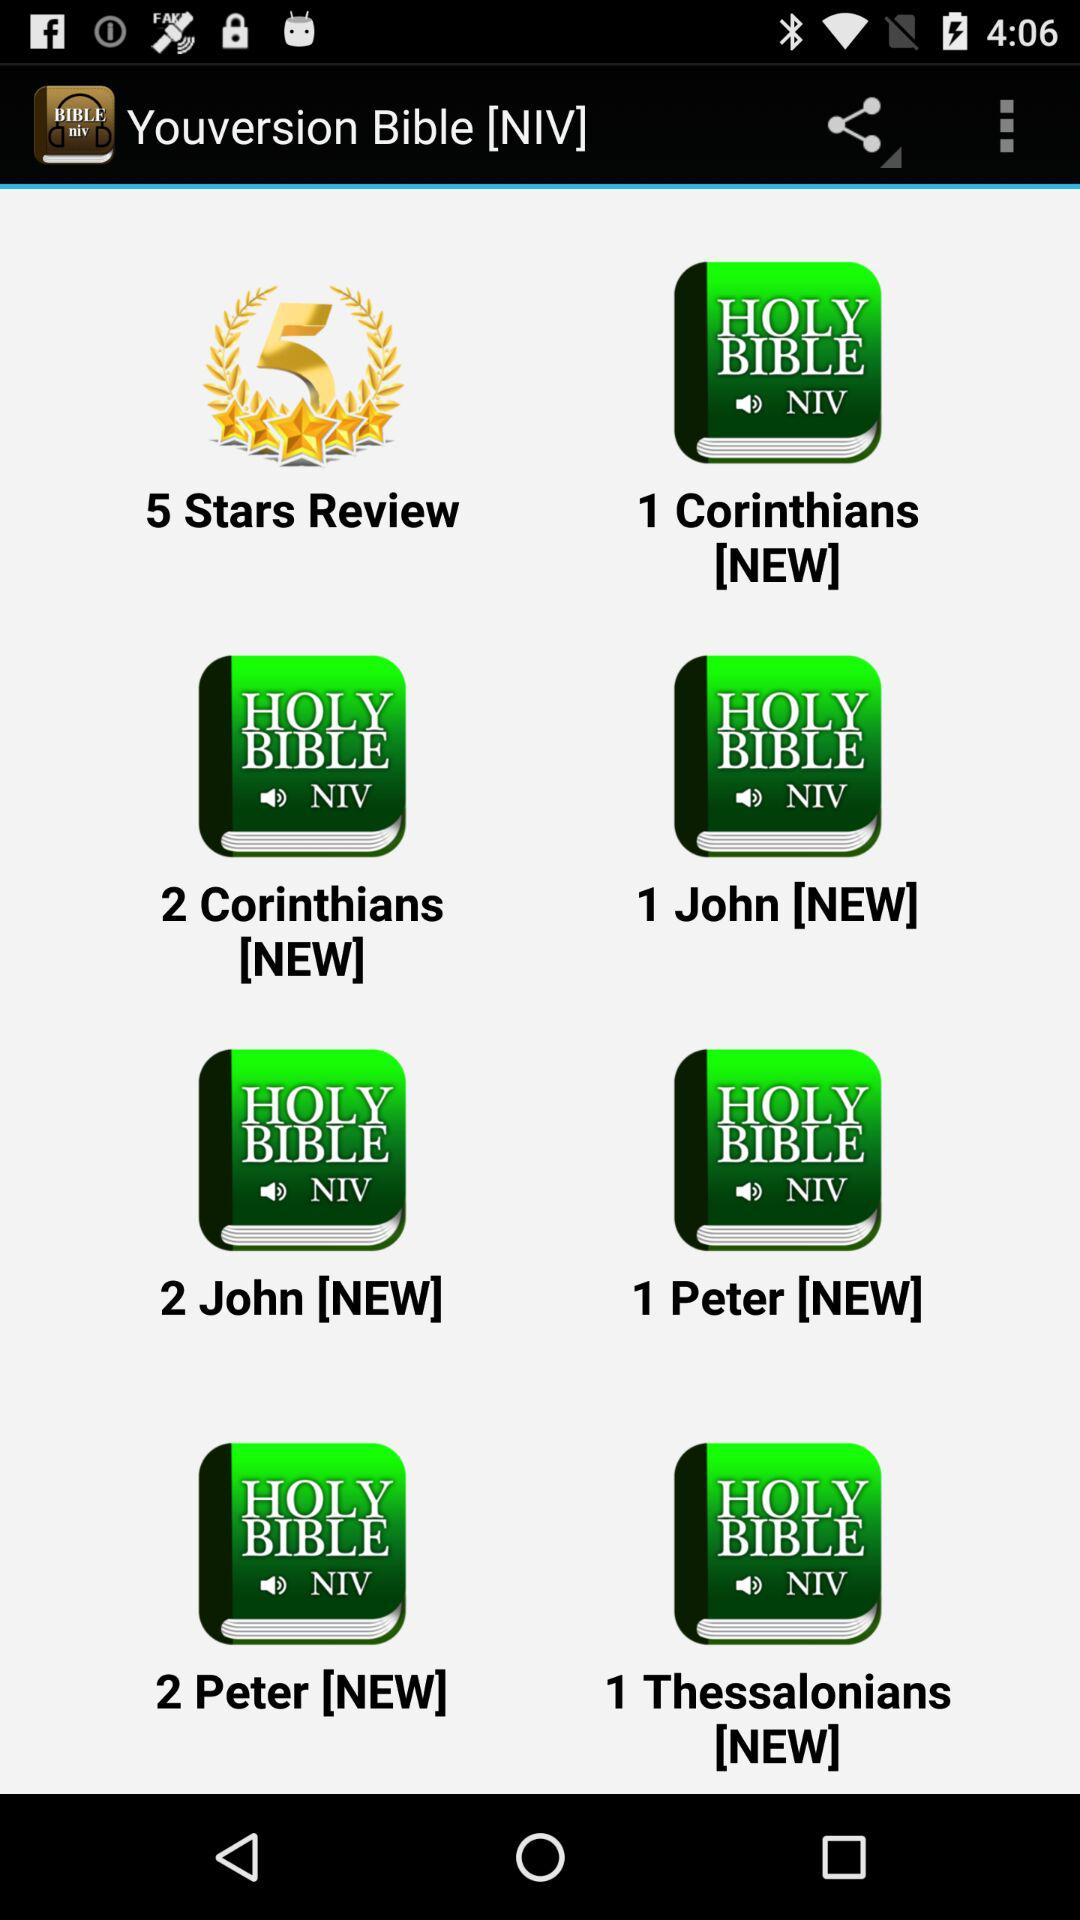What is the app name? The app name is "Youversion Bible [NIV]". 